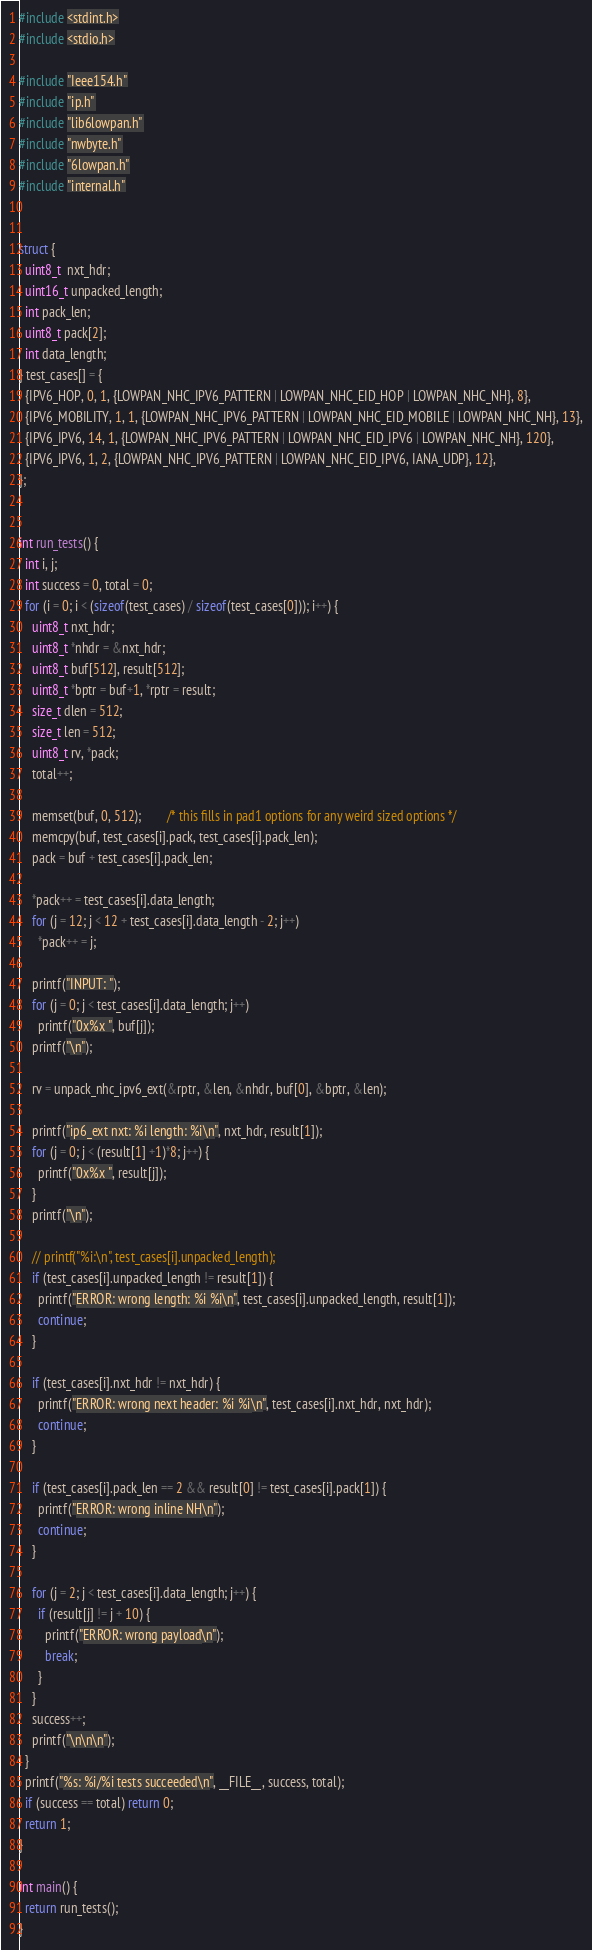Convert code to text. <code><loc_0><loc_0><loc_500><loc_500><_C_>
#include <stdint.h>
#include <stdio.h>

#include "Ieee154.h"
#include "ip.h"
#include "lib6lowpan.h"
#include "nwbyte.h"
#include "6lowpan.h"
#include "internal.h"


struct {
  uint8_t  nxt_hdr;
  uint16_t unpacked_length;
  int pack_len;
  uint8_t pack[2];
  int data_length;
} test_cases[] = {
  {IPV6_HOP, 0, 1, {LOWPAN_NHC_IPV6_PATTERN | LOWPAN_NHC_EID_HOP | LOWPAN_NHC_NH}, 8},
  {IPV6_MOBILITY, 1, 1, {LOWPAN_NHC_IPV6_PATTERN | LOWPAN_NHC_EID_MOBILE | LOWPAN_NHC_NH}, 13},
  {IPV6_IPV6, 14, 1, {LOWPAN_NHC_IPV6_PATTERN | LOWPAN_NHC_EID_IPV6 | LOWPAN_NHC_NH}, 120},
  {IPV6_IPV6, 1, 2, {LOWPAN_NHC_IPV6_PATTERN | LOWPAN_NHC_EID_IPV6, IANA_UDP}, 12},
};


int run_tests() {
  int i, j;
  int success = 0, total = 0;
  for (i = 0; i < (sizeof(test_cases) / sizeof(test_cases[0])); i++) {
    uint8_t nxt_hdr;
    uint8_t *nhdr = &nxt_hdr;
    uint8_t buf[512], result[512];
    uint8_t *bptr = buf+1, *rptr = result;
    size_t dlen = 512;
    size_t len = 512;
    uint8_t rv, *pack;
    total++;

    memset(buf, 0, 512);        /* this fills in pad1 options for any weird sized options */
    memcpy(buf, test_cases[i].pack, test_cases[i].pack_len);
    pack = buf + test_cases[i].pack_len;

    *pack++ = test_cases[i].data_length;
    for (j = 12; j < 12 + test_cases[i].data_length - 2; j++)
      *pack++ = j;

    printf("INPUT: ");
    for (j = 0; j < test_cases[i].data_length; j++)
      printf("0x%x ", buf[j]);
    printf("\n");

    rv = unpack_nhc_ipv6_ext(&rptr, &len, &nhdr, buf[0], &bptr, &len);

    printf("ip6_ext nxt: %i length: %i\n", nxt_hdr, result[1]);
    for (j = 0; j < (result[1] +1)*8; j++) {
      printf("0x%x ", result[j]);
    }
    printf("\n");

    // printf("%i:\n", test_cases[i].unpacked_length);
    if (test_cases[i].unpacked_length != result[1]) {
      printf("ERROR: wrong length: %i %i\n", test_cases[i].unpacked_length, result[1]);
      continue;
    }

    if (test_cases[i].nxt_hdr != nxt_hdr) {
      printf("ERROR: wrong next header: %i %i\n", test_cases[i].nxt_hdr, nxt_hdr);
      continue;
    }

    if (test_cases[i].pack_len == 2 && result[0] != test_cases[i].pack[1]) {
      printf("ERROR: wrong inline NH\n");
      continue;
    }

    for (j = 2; j < test_cases[i].data_length; j++) {
      if (result[j] != j + 10) {
        printf("ERROR: wrong payload\n");
        break;
      }
    }
    success++;
    printf("\n\n\n");
  }
  printf("%s: %i/%i tests succeeded\n", __FILE__, success, total);
  if (success == total) return 0;
  return 1;
}

int main() {
  return run_tests();
}
</code> 